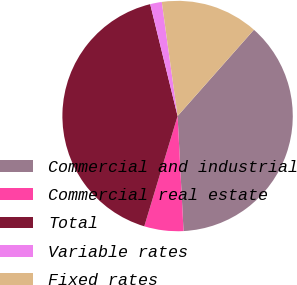<chart> <loc_0><loc_0><loc_500><loc_500><pie_chart><fcel>Commercial and industrial<fcel>Commercial real estate<fcel>Total<fcel>Variable rates<fcel>Fixed rates<nl><fcel>37.65%<fcel>5.49%<fcel>41.51%<fcel>1.63%<fcel>13.72%<nl></chart> 